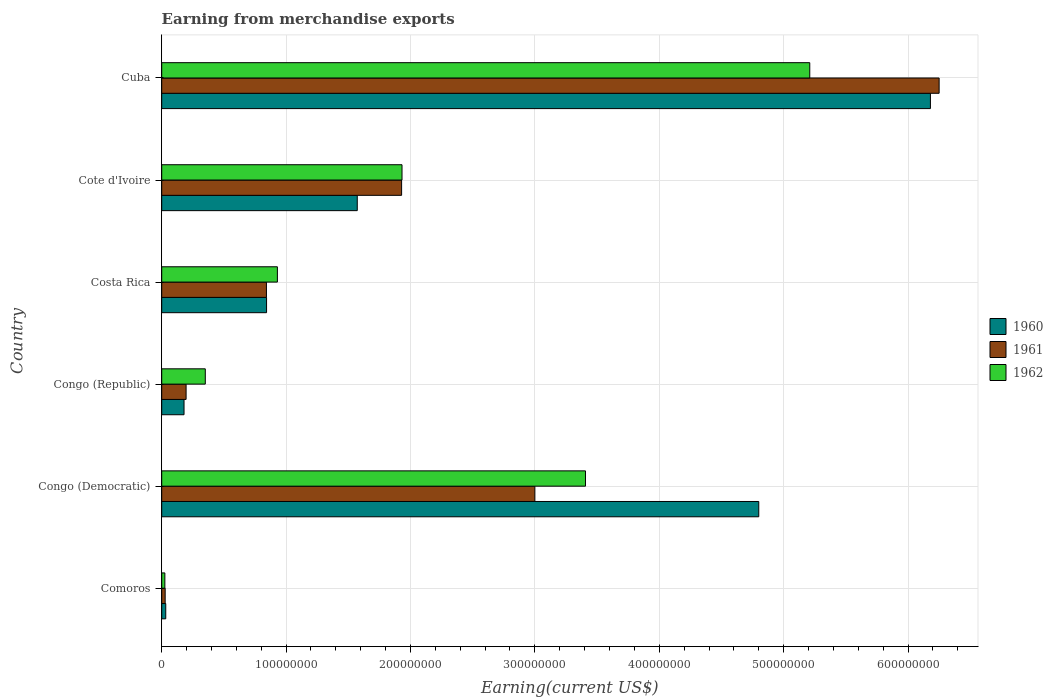How many different coloured bars are there?
Your answer should be very brief. 3. How many groups of bars are there?
Provide a short and direct response. 6. Are the number of bars on each tick of the Y-axis equal?
Provide a short and direct response. Yes. What is the label of the 6th group of bars from the top?
Keep it short and to the point. Comoros. In how many cases, is the number of bars for a given country not equal to the number of legend labels?
Ensure brevity in your answer.  0. What is the amount earned from merchandise exports in 1962 in Cote d'Ivoire?
Provide a short and direct response. 1.93e+08. Across all countries, what is the maximum amount earned from merchandise exports in 1960?
Ensure brevity in your answer.  6.18e+08. Across all countries, what is the minimum amount earned from merchandise exports in 1962?
Give a very brief answer. 2.54e+06. In which country was the amount earned from merchandise exports in 1962 maximum?
Offer a terse response. Cuba. In which country was the amount earned from merchandise exports in 1961 minimum?
Give a very brief answer. Comoros. What is the total amount earned from merchandise exports in 1960 in the graph?
Make the answer very short. 1.36e+09. What is the difference between the amount earned from merchandise exports in 1961 in Comoros and that in Cote d'Ivoire?
Give a very brief answer. -1.90e+08. What is the difference between the amount earned from merchandise exports in 1961 in Cuba and the amount earned from merchandise exports in 1960 in Costa Rica?
Offer a very short reply. 5.41e+08. What is the average amount earned from merchandise exports in 1962 per country?
Keep it short and to the point. 1.98e+08. What is the difference between the amount earned from merchandise exports in 1962 and amount earned from merchandise exports in 1961 in Cote d'Ivoire?
Give a very brief answer. 3.24e+05. What is the ratio of the amount earned from merchandise exports in 1962 in Cote d'Ivoire to that in Cuba?
Provide a short and direct response. 0.37. Is the amount earned from merchandise exports in 1960 in Congo (Republic) less than that in Cote d'Ivoire?
Offer a very short reply. Yes. Is the difference between the amount earned from merchandise exports in 1962 in Costa Rica and Cuba greater than the difference between the amount earned from merchandise exports in 1961 in Costa Rica and Cuba?
Keep it short and to the point. Yes. What is the difference between the highest and the second highest amount earned from merchandise exports in 1961?
Your answer should be very brief. 3.25e+08. What is the difference between the highest and the lowest amount earned from merchandise exports in 1960?
Your answer should be compact. 6.15e+08. Is the sum of the amount earned from merchandise exports in 1960 in Comoros and Cote d'Ivoire greater than the maximum amount earned from merchandise exports in 1961 across all countries?
Keep it short and to the point. No. What does the 3rd bar from the top in Costa Rica represents?
Your response must be concise. 1960. Is it the case that in every country, the sum of the amount earned from merchandise exports in 1962 and amount earned from merchandise exports in 1961 is greater than the amount earned from merchandise exports in 1960?
Provide a succinct answer. Yes. Are all the bars in the graph horizontal?
Give a very brief answer. Yes. How many countries are there in the graph?
Offer a terse response. 6. Does the graph contain any zero values?
Provide a short and direct response. No. What is the title of the graph?
Provide a succinct answer. Earning from merchandise exports. Does "1981" appear as one of the legend labels in the graph?
Make the answer very short. No. What is the label or title of the X-axis?
Offer a terse response. Earning(current US$). What is the label or title of the Y-axis?
Offer a very short reply. Country. What is the Earning(current US$) in 1960 in Comoros?
Offer a terse response. 3.24e+06. What is the Earning(current US$) in 1961 in Comoros?
Your answer should be very brief. 2.78e+06. What is the Earning(current US$) of 1962 in Comoros?
Provide a short and direct response. 2.54e+06. What is the Earning(current US$) in 1960 in Congo (Democratic)?
Offer a terse response. 4.80e+08. What is the Earning(current US$) of 1961 in Congo (Democratic)?
Your response must be concise. 3.00e+08. What is the Earning(current US$) of 1962 in Congo (Democratic)?
Your answer should be compact. 3.41e+08. What is the Earning(current US$) in 1960 in Congo (Republic)?
Make the answer very short. 1.79e+07. What is the Earning(current US$) in 1961 in Congo (Republic)?
Keep it short and to the point. 1.96e+07. What is the Earning(current US$) of 1962 in Congo (Republic)?
Your answer should be very brief. 3.50e+07. What is the Earning(current US$) in 1960 in Costa Rica?
Your answer should be very brief. 8.43e+07. What is the Earning(current US$) of 1961 in Costa Rica?
Make the answer very short. 8.42e+07. What is the Earning(current US$) of 1962 in Costa Rica?
Ensure brevity in your answer.  9.30e+07. What is the Earning(current US$) in 1960 in Cote d'Ivoire?
Give a very brief answer. 1.57e+08. What is the Earning(current US$) in 1961 in Cote d'Ivoire?
Ensure brevity in your answer.  1.93e+08. What is the Earning(current US$) of 1962 in Cote d'Ivoire?
Provide a short and direct response. 1.93e+08. What is the Earning(current US$) in 1960 in Cuba?
Offer a terse response. 6.18e+08. What is the Earning(current US$) in 1961 in Cuba?
Keep it short and to the point. 6.25e+08. What is the Earning(current US$) in 1962 in Cuba?
Your answer should be compact. 5.21e+08. Across all countries, what is the maximum Earning(current US$) of 1960?
Your response must be concise. 6.18e+08. Across all countries, what is the maximum Earning(current US$) in 1961?
Offer a terse response. 6.25e+08. Across all countries, what is the maximum Earning(current US$) in 1962?
Your answer should be very brief. 5.21e+08. Across all countries, what is the minimum Earning(current US$) in 1960?
Your answer should be compact. 3.24e+06. Across all countries, what is the minimum Earning(current US$) of 1961?
Give a very brief answer. 2.78e+06. Across all countries, what is the minimum Earning(current US$) of 1962?
Provide a succinct answer. 2.54e+06. What is the total Earning(current US$) in 1960 in the graph?
Your answer should be very brief. 1.36e+09. What is the total Earning(current US$) of 1961 in the graph?
Offer a terse response. 1.22e+09. What is the total Earning(current US$) in 1962 in the graph?
Give a very brief answer. 1.19e+09. What is the difference between the Earning(current US$) of 1960 in Comoros and that in Congo (Democratic)?
Ensure brevity in your answer.  -4.77e+08. What is the difference between the Earning(current US$) in 1961 in Comoros and that in Congo (Democratic)?
Offer a terse response. -2.97e+08. What is the difference between the Earning(current US$) in 1962 in Comoros and that in Congo (Democratic)?
Provide a short and direct response. -3.38e+08. What is the difference between the Earning(current US$) in 1960 in Comoros and that in Congo (Republic)?
Offer a terse response. -1.47e+07. What is the difference between the Earning(current US$) of 1961 in Comoros and that in Congo (Republic)?
Give a very brief answer. -1.68e+07. What is the difference between the Earning(current US$) of 1962 in Comoros and that in Congo (Republic)?
Provide a succinct answer. -3.25e+07. What is the difference between the Earning(current US$) of 1960 in Comoros and that in Costa Rica?
Keep it short and to the point. -8.11e+07. What is the difference between the Earning(current US$) in 1961 in Comoros and that in Costa Rica?
Provide a short and direct response. -8.14e+07. What is the difference between the Earning(current US$) of 1962 in Comoros and that in Costa Rica?
Your response must be concise. -9.05e+07. What is the difference between the Earning(current US$) of 1960 in Comoros and that in Cote d'Ivoire?
Offer a terse response. -1.54e+08. What is the difference between the Earning(current US$) of 1961 in Comoros and that in Cote d'Ivoire?
Your answer should be compact. -1.90e+08. What is the difference between the Earning(current US$) in 1962 in Comoros and that in Cote d'Ivoire?
Make the answer very short. -1.91e+08. What is the difference between the Earning(current US$) in 1960 in Comoros and that in Cuba?
Give a very brief answer. -6.15e+08. What is the difference between the Earning(current US$) in 1961 in Comoros and that in Cuba?
Offer a terse response. -6.22e+08. What is the difference between the Earning(current US$) of 1962 in Comoros and that in Cuba?
Offer a very short reply. -5.18e+08. What is the difference between the Earning(current US$) of 1960 in Congo (Democratic) and that in Congo (Republic)?
Your response must be concise. 4.62e+08. What is the difference between the Earning(current US$) of 1961 in Congo (Democratic) and that in Congo (Republic)?
Give a very brief answer. 2.80e+08. What is the difference between the Earning(current US$) in 1962 in Congo (Democratic) and that in Congo (Republic)?
Keep it short and to the point. 3.06e+08. What is the difference between the Earning(current US$) of 1960 in Congo (Democratic) and that in Costa Rica?
Keep it short and to the point. 3.96e+08. What is the difference between the Earning(current US$) in 1961 in Congo (Democratic) and that in Costa Rica?
Your answer should be very brief. 2.16e+08. What is the difference between the Earning(current US$) in 1962 in Congo (Democratic) and that in Costa Rica?
Keep it short and to the point. 2.48e+08. What is the difference between the Earning(current US$) of 1960 in Congo (Democratic) and that in Cote d'Ivoire?
Your answer should be compact. 3.23e+08. What is the difference between the Earning(current US$) in 1961 in Congo (Democratic) and that in Cote d'Ivoire?
Make the answer very short. 1.07e+08. What is the difference between the Earning(current US$) of 1962 in Congo (Democratic) and that in Cote d'Ivoire?
Offer a terse response. 1.48e+08. What is the difference between the Earning(current US$) in 1960 in Congo (Democratic) and that in Cuba?
Ensure brevity in your answer.  -1.38e+08. What is the difference between the Earning(current US$) in 1961 in Congo (Democratic) and that in Cuba?
Keep it short and to the point. -3.25e+08. What is the difference between the Earning(current US$) of 1962 in Congo (Democratic) and that in Cuba?
Keep it short and to the point. -1.80e+08. What is the difference between the Earning(current US$) of 1960 in Congo (Republic) and that in Costa Rica?
Provide a short and direct response. -6.64e+07. What is the difference between the Earning(current US$) of 1961 in Congo (Republic) and that in Costa Rica?
Your answer should be very brief. -6.46e+07. What is the difference between the Earning(current US$) of 1962 in Congo (Republic) and that in Costa Rica?
Offer a terse response. -5.80e+07. What is the difference between the Earning(current US$) of 1960 in Congo (Republic) and that in Cote d'Ivoire?
Provide a succinct answer. -1.39e+08. What is the difference between the Earning(current US$) of 1961 in Congo (Republic) and that in Cote d'Ivoire?
Your answer should be compact. -1.73e+08. What is the difference between the Earning(current US$) in 1962 in Congo (Republic) and that in Cote d'Ivoire?
Give a very brief answer. -1.58e+08. What is the difference between the Earning(current US$) in 1960 in Congo (Republic) and that in Cuba?
Give a very brief answer. -6.00e+08. What is the difference between the Earning(current US$) of 1961 in Congo (Republic) and that in Cuba?
Provide a short and direct response. -6.05e+08. What is the difference between the Earning(current US$) of 1962 in Congo (Republic) and that in Cuba?
Provide a succinct answer. -4.86e+08. What is the difference between the Earning(current US$) in 1960 in Costa Rica and that in Cote d'Ivoire?
Offer a very short reply. -7.29e+07. What is the difference between the Earning(current US$) of 1961 in Costa Rica and that in Cote d'Ivoire?
Offer a terse response. -1.09e+08. What is the difference between the Earning(current US$) of 1962 in Costa Rica and that in Cote d'Ivoire?
Give a very brief answer. -1.00e+08. What is the difference between the Earning(current US$) in 1960 in Costa Rica and that in Cuba?
Provide a succinct answer. -5.34e+08. What is the difference between the Earning(current US$) in 1961 in Costa Rica and that in Cuba?
Your response must be concise. -5.41e+08. What is the difference between the Earning(current US$) in 1962 in Costa Rica and that in Cuba?
Ensure brevity in your answer.  -4.28e+08. What is the difference between the Earning(current US$) of 1960 in Cote d'Ivoire and that in Cuba?
Ensure brevity in your answer.  -4.61e+08. What is the difference between the Earning(current US$) of 1961 in Cote d'Ivoire and that in Cuba?
Give a very brief answer. -4.32e+08. What is the difference between the Earning(current US$) in 1962 in Cote d'Ivoire and that in Cuba?
Keep it short and to the point. -3.28e+08. What is the difference between the Earning(current US$) in 1960 in Comoros and the Earning(current US$) in 1961 in Congo (Democratic)?
Offer a very short reply. -2.97e+08. What is the difference between the Earning(current US$) in 1960 in Comoros and the Earning(current US$) in 1962 in Congo (Democratic)?
Provide a short and direct response. -3.37e+08. What is the difference between the Earning(current US$) of 1961 in Comoros and the Earning(current US$) of 1962 in Congo (Democratic)?
Provide a succinct answer. -3.38e+08. What is the difference between the Earning(current US$) of 1960 in Comoros and the Earning(current US$) of 1961 in Congo (Republic)?
Keep it short and to the point. -1.64e+07. What is the difference between the Earning(current US$) of 1960 in Comoros and the Earning(current US$) of 1962 in Congo (Republic)?
Provide a succinct answer. -3.18e+07. What is the difference between the Earning(current US$) in 1961 in Comoros and the Earning(current US$) in 1962 in Congo (Republic)?
Make the answer very short. -3.23e+07. What is the difference between the Earning(current US$) of 1960 in Comoros and the Earning(current US$) of 1961 in Costa Rica?
Your response must be concise. -8.10e+07. What is the difference between the Earning(current US$) of 1960 in Comoros and the Earning(current US$) of 1962 in Costa Rica?
Provide a short and direct response. -8.98e+07. What is the difference between the Earning(current US$) in 1961 in Comoros and the Earning(current US$) in 1962 in Costa Rica?
Offer a terse response. -9.02e+07. What is the difference between the Earning(current US$) in 1960 in Comoros and the Earning(current US$) in 1961 in Cote d'Ivoire?
Your answer should be very brief. -1.90e+08. What is the difference between the Earning(current US$) of 1960 in Comoros and the Earning(current US$) of 1962 in Cote d'Ivoire?
Keep it short and to the point. -1.90e+08. What is the difference between the Earning(current US$) in 1961 in Comoros and the Earning(current US$) in 1962 in Cote d'Ivoire?
Offer a very short reply. -1.90e+08. What is the difference between the Earning(current US$) of 1960 in Comoros and the Earning(current US$) of 1961 in Cuba?
Keep it short and to the point. -6.22e+08. What is the difference between the Earning(current US$) of 1960 in Comoros and the Earning(current US$) of 1962 in Cuba?
Offer a very short reply. -5.18e+08. What is the difference between the Earning(current US$) in 1961 in Comoros and the Earning(current US$) in 1962 in Cuba?
Your answer should be compact. -5.18e+08. What is the difference between the Earning(current US$) of 1960 in Congo (Democratic) and the Earning(current US$) of 1961 in Congo (Republic)?
Give a very brief answer. 4.60e+08. What is the difference between the Earning(current US$) in 1960 in Congo (Democratic) and the Earning(current US$) in 1962 in Congo (Republic)?
Your answer should be compact. 4.45e+08. What is the difference between the Earning(current US$) in 1961 in Congo (Democratic) and the Earning(current US$) in 1962 in Congo (Republic)?
Provide a short and direct response. 2.65e+08. What is the difference between the Earning(current US$) of 1960 in Congo (Democratic) and the Earning(current US$) of 1961 in Costa Rica?
Give a very brief answer. 3.96e+08. What is the difference between the Earning(current US$) in 1960 in Congo (Democratic) and the Earning(current US$) in 1962 in Costa Rica?
Provide a succinct answer. 3.87e+08. What is the difference between the Earning(current US$) in 1961 in Congo (Democratic) and the Earning(current US$) in 1962 in Costa Rica?
Make the answer very short. 2.07e+08. What is the difference between the Earning(current US$) in 1960 in Congo (Democratic) and the Earning(current US$) in 1961 in Cote d'Ivoire?
Give a very brief answer. 2.87e+08. What is the difference between the Earning(current US$) in 1960 in Congo (Democratic) and the Earning(current US$) in 1962 in Cote d'Ivoire?
Ensure brevity in your answer.  2.87e+08. What is the difference between the Earning(current US$) of 1961 in Congo (Democratic) and the Earning(current US$) of 1962 in Cote d'Ivoire?
Your answer should be compact. 1.07e+08. What is the difference between the Earning(current US$) of 1960 in Congo (Democratic) and the Earning(current US$) of 1961 in Cuba?
Provide a short and direct response. -1.45e+08. What is the difference between the Earning(current US$) in 1960 in Congo (Democratic) and the Earning(current US$) in 1962 in Cuba?
Your response must be concise. -4.10e+07. What is the difference between the Earning(current US$) in 1961 in Congo (Democratic) and the Earning(current US$) in 1962 in Cuba?
Offer a terse response. -2.21e+08. What is the difference between the Earning(current US$) in 1960 in Congo (Republic) and the Earning(current US$) in 1961 in Costa Rica?
Your response must be concise. -6.63e+07. What is the difference between the Earning(current US$) in 1960 in Congo (Republic) and the Earning(current US$) in 1962 in Costa Rica?
Make the answer very short. -7.51e+07. What is the difference between the Earning(current US$) of 1961 in Congo (Republic) and the Earning(current US$) of 1962 in Costa Rica?
Make the answer very short. -7.34e+07. What is the difference between the Earning(current US$) of 1960 in Congo (Republic) and the Earning(current US$) of 1961 in Cote d'Ivoire?
Your response must be concise. -1.75e+08. What is the difference between the Earning(current US$) in 1960 in Congo (Republic) and the Earning(current US$) in 1962 in Cote d'Ivoire?
Offer a very short reply. -1.75e+08. What is the difference between the Earning(current US$) of 1961 in Congo (Republic) and the Earning(current US$) of 1962 in Cote d'Ivoire?
Your answer should be compact. -1.74e+08. What is the difference between the Earning(current US$) of 1960 in Congo (Republic) and the Earning(current US$) of 1961 in Cuba?
Offer a very short reply. -6.07e+08. What is the difference between the Earning(current US$) in 1960 in Congo (Republic) and the Earning(current US$) in 1962 in Cuba?
Your answer should be very brief. -5.03e+08. What is the difference between the Earning(current US$) in 1961 in Congo (Republic) and the Earning(current US$) in 1962 in Cuba?
Your response must be concise. -5.01e+08. What is the difference between the Earning(current US$) in 1960 in Costa Rica and the Earning(current US$) in 1961 in Cote d'Ivoire?
Provide a succinct answer. -1.09e+08. What is the difference between the Earning(current US$) in 1960 in Costa Rica and the Earning(current US$) in 1962 in Cote d'Ivoire?
Provide a succinct answer. -1.09e+08. What is the difference between the Earning(current US$) in 1961 in Costa Rica and the Earning(current US$) in 1962 in Cote d'Ivoire?
Make the answer very short. -1.09e+08. What is the difference between the Earning(current US$) in 1960 in Costa Rica and the Earning(current US$) in 1961 in Cuba?
Provide a succinct answer. -5.41e+08. What is the difference between the Earning(current US$) in 1960 in Costa Rica and the Earning(current US$) in 1962 in Cuba?
Ensure brevity in your answer.  -4.37e+08. What is the difference between the Earning(current US$) of 1961 in Costa Rica and the Earning(current US$) of 1962 in Cuba?
Ensure brevity in your answer.  -4.37e+08. What is the difference between the Earning(current US$) in 1960 in Cote d'Ivoire and the Earning(current US$) in 1961 in Cuba?
Keep it short and to the point. -4.68e+08. What is the difference between the Earning(current US$) in 1960 in Cote d'Ivoire and the Earning(current US$) in 1962 in Cuba?
Your response must be concise. -3.64e+08. What is the difference between the Earning(current US$) of 1961 in Cote d'Ivoire and the Earning(current US$) of 1962 in Cuba?
Your response must be concise. -3.28e+08. What is the average Earning(current US$) in 1960 per country?
Your response must be concise. 2.27e+08. What is the average Earning(current US$) in 1961 per country?
Provide a short and direct response. 2.04e+08. What is the average Earning(current US$) in 1962 per country?
Ensure brevity in your answer.  1.98e+08. What is the difference between the Earning(current US$) in 1960 and Earning(current US$) in 1961 in Comoros?
Your answer should be very brief. 4.62e+05. What is the difference between the Earning(current US$) in 1960 and Earning(current US$) in 1962 in Comoros?
Your response must be concise. 7.05e+05. What is the difference between the Earning(current US$) in 1961 and Earning(current US$) in 1962 in Comoros?
Offer a very short reply. 2.43e+05. What is the difference between the Earning(current US$) in 1960 and Earning(current US$) in 1961 in Congo (Democratic)?
Ensure brevity in your answer.  1.80e+08. What is the difference between the Earning(current US$) of 1960 and Earning(current US$) of 1962 in Congo (Democratic)?
Keep it short and to the point. 1.39e+08. What is the difference between the Earning(current US$) of 1961 and Earning(current US$) of 1962 in Congo (Democratic)?
Keep it short and to the point. -4.07e+07. What is the difference between the Earning(current US$) of 1960 and Earning(current US$) of 1961 in Congo (Republic)?
Offer a very short reply. -1.66e+06. What is the difference between the Earning(current US$) of 1960 and Earning(current US$) of 1962 in Congo (Republic)?
Your response must be concise. -1.71e+07. What is the difference between the Earning(current US$) in 1961 and Earning(current US$) in 1962 in Congo (Republic)?
Make the answer very short. -1.54e+07. What is the difference between the Earning(current US$) in 1960 and Earning(current US$) in 1961 in Costa Rica?
Your answer should be compact. 1.00e+05. What is the difference between the Earning(current US$) of 1960 and Earning(current US$) of 1962 in Costa Rica?
Give a very brief answer. -8.70e+06. What is the difference between the Earning(current US$) of 1961 and Earning(current US$) of 1962 in Costa Rica?
Offer a very short reply. -8.80e+06. What is the difference between the Earning(current US$) of 1960 and Earning(current US$) of 1961 in Cote d'Ivoire?
Provide a succinct answer. -3.56e+07. What is the difference between the Earning(current US$) of 1960 and Earning(current US$) of 1962 in Cote d'Ivoire?
Provide a succinct answer. -3.60e+07. What is the difference between the Earning(current US$) of 1961 and Earning(current US$) of 1962 in Cote d'Ivoire?
Keep it short and to the point. -3.24e+05. What is the difference between the Earning(current US$) in 1960 and Earning(current US$) in 1961 in Cuba?
Give a very brief answer. -7.00e+06. What is the difference between the Earning(current US$) in 1960 and Earning(current US$) in 1962 in Cuba?
Offer a very short reply. 9.70e+07. What is the difference between the Earning(current US$) of 1961 and Earning(current US$) of 1962 in Cuba?
Make the answer very short. 1.04e+08. What is the ratio of the Earning(current US$) of 1960 in Comoros to that in Congo (Democratic)?
Keep it short and to the point. 0.01. What is the ratio of the Earning(current US$) of 1961 in Comoros to that in Congo (Democratic)?
Provide a succinct answer. 0.01. What is the ratio of the Earning(current US$) of 1962 in Comoros to that in Congo (Democratic)?
Your answer should be compact. 0.01. What is the ratio of the Earning(current US$) in 1960 in Comoros to that in Congo (Republic)?
Offer a very short reply. 0.18. What is the ratio of the Earning(current US$) of 1961 in Comoros to that in Congo (Republic)?
Your answer should be very brief. 0.14. What is the ratio of the Earning(current US$) of 1962 in Comoros to that in Congo (Republic)?
Provide a succinct answer. 0.07. What is the ratio of the Earning(current US$) of 1960 in Comoros to that in Costa Rica?
Provide a succinct answer. 0.04. What is the ratio of the Earning(current US$) of 1961 in Comoros to that in Costa Rica?
Offer a very short reply. 0.03. What is the ratio of the Earning(current US$) of 1962 in Comoros to that in Costa Rica?
Offer a terse response. 0.03. What is the ratio of the Earning(current US$) in 1960 in Comoros to that in Cote d'Ivoire?
Offer a terse response. 0.02. What is the ratio of the Earning(current US$) in 1961 in Comoros to that in Cote d'Ivoire?
Keep it short and to the point. 0.01. What is the ratio of the Earning(current US$) of 1962 in Comoros to that in Cote d'Ivoire?
Provide a short and direct response. 0.01. What is the ratio of the Earning(current US$) of 1960 in Comoros to that in Cuba?
Your answer should be compact. 0.01. What is the ratio of the Earning(current US$) of 1961 in Comoros to that in Cuba?
Offer a terse response. 0. What is the ratio of the Earning(current US$) of 1962 in Comoros to that in Cuba?
Keep it short and to the point. 0. What is the ratio of the Earning(current US$) in 1960 in Congo (Democratic) to that in Congo (Republic)?
Give a very brief answer. 26.75. What is the ratio of the Earning(current US$) of 1961 in Congo (Democratic) to that in Congo (Republic)?
Offer a terse response. 15.3. What is the ratio of the Earning(current US$) of 1962 in Congo (Democratic) to that in Congo (Republic)?
Your answer should be very brief. 9.72. What is the ratio of the Earning(current US$) in 1960 in Congo (Democratic) to that in Costa Rica?
Provide a short and direct response. 5.69. What is the ratio of the Earning(current US$) of 1961 in Congo (Democratic) to that in Costa Rica?
Your answer should be very brief. 3.56. What is the ratio of the Earning(current US$) in 1962 in Congo (Democratic) to that in Costa Rica?
Your answer should be very brief. 3.66. What is the ratio of the Earning(current US$) in 1960 in Congo (Democratic) to that in Cote d'Ivoire?
Your answer should be very brief. 3.05. What is the ratio of the Earning(current US$) in 1961 in Congo (Democratic) to that in Cote d'Ivoire?
Provide a succinct answer. 1.56. What is the ratio of the Earning(current US$) in 1962 in Congo (Democratic) to that in Cote d'Ivoire?
Ensure brevity in your answer.  1.76. What is the ratio of the Earning(current US$) in 1960 in Congo (Democratic) to that in Cuba?
Your response must be concise. 0.78. What is the ratio of the Earning(current US$) in 1961 in Congo (Democratic) to that in Cuba?
Your answer should be very brief. 0.48. What is the ratio of the Earning(current US$) of 1962 in Congo (Democratic) to that in Cuba?
Provide a succinct answer. 0.65. What is the ratio of the Earning(current US$) in 1960 in Congo (Republic) to that in Costa Rica?
Offer a terse response. 0.21. What is the ratio of the Earning(current US$) in 1961 in Congo (Republic) to that in Costa Rica?
Keep it short and to the point. 0.23. What is the ratio of the Earning(current US$) of 1962 in Congo (Republic) to that in Costa Rica?
Your answer should be compact. 0.38. What is the ratio of the Earning(current US$) of 1960 in Congo (Republic) to that in Cote d'Ivoire?
Ensure brevity in your answer.  0.11. What is the ratio of the Earning(current US$) of 1961 in Congo (Republic) to that in Cote d'Ivoire?
Ensure brevity in your answer.  0.1. What is the ratio of the Earning(current US$) of 1962 in Congo (Republic) to that in Cote d'Ivoire?
Your answer should be very brief. 0.18. What is the ratio of the Earning(current US$) in 1960 in Congo (Republic) to that in Cuba?
Your response must be concise. 0.03. What is the ratio of the Earning(current US$) of 1961 in Congo (Republic) to that in Cuba?
Your answer should be very brief. 0.03. What is the ratio of the Earning(current US$) of 1962 in Congo (Republic) to that in Cuba?
Your response must be concise. 0.07. What is the ratio of the Earning(current US$) of 1960 in Costa Rica to that in Cote d'Ivoire?
Provide a short and direct response. 0.54. What is the ratio of the Earning(current US$) of 1961 in Costa Rica to that in Cote d'Ivoire?
Keep it short and to the point. 0.44. What is the ratio of the Earning(current US$) of 1962 in Costa Rica to that in Cote d'Ivoire?
Offer a terse response. 0.48. What is the ratio of the Earning(current US$) in 1960 in Costa Rica to that in Cuba?
Your answer should be very brief. 0.14. What is the ratio of the Earning(current US$) of 1961 in Costa Rica to that in Cuba?
Make the answer very short. 0.13. What is the ratio of the Earning(current US$) of 1962 in Costa Rica to that in Cuba?
Offer a very short reply. 0.18. What is the ratio of the Earning(current US$) in 1960 in Cote d'Ivoire to that in Cuba?
Make the answer very short. 0.25. What is the ratio of the Earning(current US$) in 1961 in Cote d'Ivoire to that in Cuba?
Offer a terse response. 0.31. What is the ratio of the Earning(current US$) of 1962 in Cote d'Ivoire to that in Cuba?
Ensure brevity in your answer.  0.37. What is the difference between the highest and the second highest Earning(current US$) of 1960?
Offer a terse response. 1.38e+08. What is the difference between the highest and the second highest Earning(current US$) of 1961?
Your answer should be very brief. 3.25e+08. What is the difference between the highest and the second highest Earning(current US$) in 1962?
Your answer should be compact. 1.80e+08. What is the difference between the highest and the lowest Earning(current US$) of 1960?
Keep it short and to the point. 6.15e+08. What is the difference between the highest and the lowest Earning(current US$) in 1961?
Provide a succinct answer. 6.22e+08. What is the difference between the highest and the lowest Earning(current US$) in 1962?
Provide a succinct answer. 5.18e+08. 